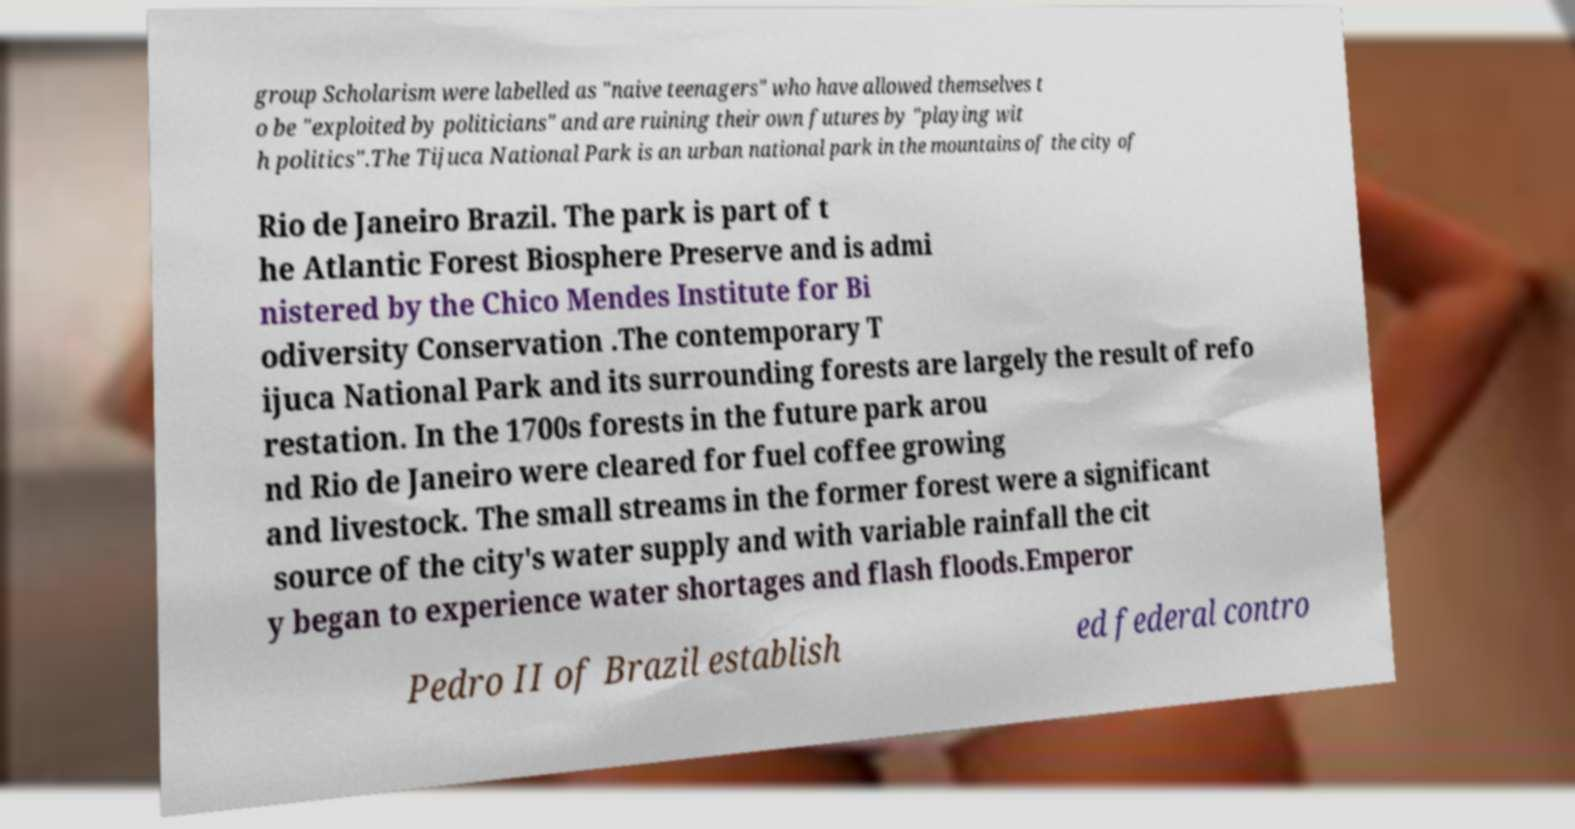Could you extract and type out the text from this image? group Scholarism were labelled as "naive teenagers" who have allowed themselves t o be "exploited by politicians" and are ruining their own futures by "playing wit h politics".The Tijuca National Park is an urban national park in the mountains of the city of Rio de Janeiro Brazil. The park is part of t he Atlantic Forest Biosphere Preserve and is admi nistered by the Chico Mendes Institute for Bi odiversity Conservation .The contemporary T ijuca National Park and its surrounding forests are largely the result of refo restation. In the 1700s forests in the future park arou nd Rio de Janeiro were cleared for fuel coffee growing and livestock. The small streams in the former forest were a significant source of the city's water supply and with variable rainfall the cit y began to experience water shortages and flash floods.Emperor Pedro II of Brazil establish ed federal contro 